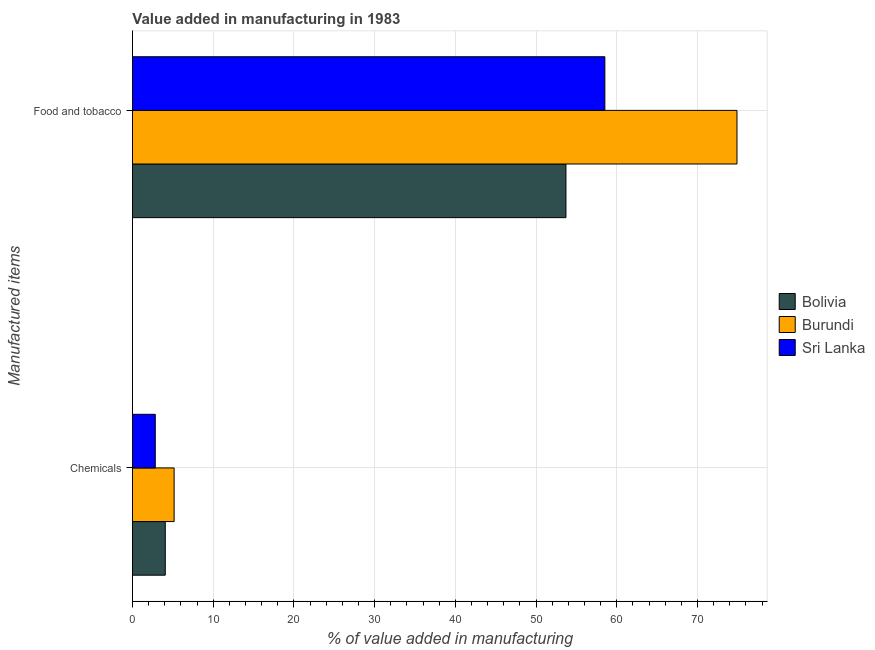Are the number of bars on each tick of the Y-axis equal?
Provide a short and direct response. Yes. How many bars are there on the 2nd tick from the bottom?
Offer a very short reply. 3. What is the label of the 1st group of bars from the top?
Make the answer very short. Food and tobacco. What is the value added by manufacturing food and tobacco in Bolivia?
Your answer should be compact. 53.7. Across all countries, what is the maximum value added by manufacturing food and tobacco?
Provide a short and direct response. 74.89. Across all countries, what is the minimum value added by manufacturing food and tobacco?
Offer a very short reply. 53.7. In which country was the value added by  manufacturing chemicals maximum?
Keep it short and to the point. Burundi. In which country was the value added by  manufacturing chemicals minimum?
Offer a terse response. Sri Lanka. What is the total value added by manufacturing food and tobacco in the graph?
Provide a short and direct response. 187.11. What is the difference between the value added by  manufacturing chemicals in Sri Lanka and that in Burundi?
Your answer should be compact. -2.34. What is the difference between the value added by manufacturing food and tobacco in Sri Lanka and the value added by  manufacturing chemicals in Burundi?
Offer a very short reply. 53.35. What is the average value added by manufacturing food and tobacco per country?
Give a very brief answer. 62.37. What is the difference between the value added by  manufacturing chemicals and value added by manufacturing food and tobacco in Sri Lanka?
Your answer should be compact. -55.69. In how many countries, is the value added by  manufacturing chemicals greater than 14 %?
Offer a very short reply. 0. What is the ratio of the value added by manufacturing food and tobacco in Sri Lanka to that in Burundi?
Your answer should be very brief. 0.78. Is the value added by  manufacturing chemicals in Burundi less than that in Bolivia?
Keep it short and to the point. No. In how many countries, is the value added by manufacturing food and tobacco greater than the average value added by manufacturing food and tobacco taken over all countries?
Offer a very short reply. 1. What does the 2nd bar from the top in Food and tobacco represents?
Provide a short and direct response. Burundi. What does the 3rd bar from the bottom in Food and tobacco represents?
Give a very brief answer. Sri Lanka. Are all the bars in the graph horizontal?
Give a very brief answer. Yes. What is the difference between two consecutive major ticks on the X-axis?
Offer a very short reply. 10. Are the values on the major ticks of X-axis written in scientific E-notation?
Provide a short and direct response. No. Does the graph contain any zero values?
Make the answer very short. No. Where does the legend appear in the graph?
Your answer should be compact. Center right. How many legend labels are there?
Provide a succinct answer. 3. What is the title of the graph?
Your response must be concise. Value added in manufacturing in 1983. Does "Philippines" appear as one of the legend labels in the graph?
Offer a terse response. No. What is the label or title of the X-axis?
Offer a terse response. % of value added in manufacturing. What is the label or title of the Y-axis?
Your answer should be compact. Manufactured items. What is the % of value added in manufacturing in Bolivia in Chemicals?
Keep it short and to the point. 4.07. What is the % of value added in manufacturing of Burundi in Chemicals?
Offer a terse response. 5.17. What is the % of value added in manufacturing of Sri Lanka in Chemicals?
Ensure brevity in your answer.  2.83. What is the % of value added in manufacturing in Bolivia in Food and tobacco?
Provide a succinct answer. 53.7. What is the % of value added in manufacturing in Burundi in Food and tobacco?
Provide a short and direct response. 74.89. What is the % of value added in manufacturing in Sri Lanka in Food and tobacco?
Offer a terse response. 58.52. Across all Manufactured items, what is the maximum % of value added in manufacturing in Bolivia?
Make the answer very short. 53.7. Across all Manufactured items, what is the maximum % of value added in manufacturing of Burundi?
Your answer should be very brief. 74.89. Across all Manufactured items, what is the maximum % of value added in manufacturing in Sri Lanka?
Offer a very short reply. 58.52. Across all Manufactured items, what is the minimum % of value added in manufacturing of Bolivia?
Give a very brief answer. 4.07. Across all Manufactured items, what is the minimum % of value added in manufacturing of Burundi?
Your answer should be compact. 5.17. Across all Manufactured items, what is the minimum % of value added in manufacturing of Sri Lanka?
Make the answer very short. 2.83. What is the total % of value added in manufacturing of Bolivia in the graph?
Offer a terse response. 57.77. What is the total % of value added in manufacturing in Burundi in the graph?
Your answer should be compact. 80.05. What is the total % of value added in manufacturing of Sri Lanka in the graph?
Offer a very short reply. 61.35. What is the difference between the % of value added in manufacturing in Bolivia in Chemicals and that in Food and tobacco?
Your answer should be compact. -49.63. What is the difference between the % of value added in manufacturing in Burundi in Chemicals and that in Food and tobacco?
Keep it short and to the point. -69.72. What is the difference between the % of value added in manufacturing of Sri Lanka in Chemicals and that in Food and tobacco?
Provide a short and direct response. -55.69. What is the difference between the % of value added in manufacturing of Bolivia in Chemicals and the % of value added in manufacturing of Burundi in Food and tobacco?
Keep it short and to the point. -70.82. What is the difference between the % of value added in manufacturing in Bolivia in Chemicals and the % of value added in manufacturing in Sri Lanka in Food and tobacco?
Your answer should be compact. -54.45. What is the difference between the % of value added in manufacturing in Burundi in Chemicals and the % of value added in manufacturing in Sri Lanka in Food and tobacco?
Make the answer very short. -53.35. What is the average % of value added in manufacturing of Bolivia per Manufactured items?
Make the answer very short. 28.88. What is the average % of value added in manufacturing of Burundi per Manufactured items?
Give a very brief answer. 40.03. What is the average % of value added in manufacturing in Sri Lanka per Manufactured items?
Provide a succinct answer. 30.68. What is the difference between the % of value added in manufacturing in Bolivia and % of value added in manufacturing in Burundi in Chemicals?
Your answer should be compact. -1.1. What is the difference between the % of value added in manufacturing in Bolivia and % of value added in manufacturing in Sri Lanka in Chemicals?
Provide a short and direct response. 1.24. What is the difference between the % of value added in manufacturing of Burundi and % of value added in manufacturing of Sri Lanka in Chemicals?
Make the answer very short. 2.34. What is the difference between the % of value added in manufacturing in Bolivia and % of value added in manufacturing in Burundi in Food and tobacco?
Give a very brief answer. -21.19. What is the difference between the % of value added in manufacturing in Bolivia and % of value added in manufacturing in Sri Lanka in Food and tobacco?
Provide a short and direct response. -4.82. What is the difference between the % of value added in manufacturing in Burundi and % of value added in manufacturing in Sri Lanka in Food and tobacco?
Offer a very short reply. 16.37. What is the ratio of the % of value added in manufacturing in Bolivia in Chemicals to that in Food and tobacco?
Give a very brief answer. 0.08. What is the ratio of the % of value added in manufacturing of Burundi in Chemicals to that in Food and tobacco?
Your answer should be very brief. 0.07. What is the ratio of the % of value added in manufacturing of Sri Lanka in Chemicals to that in Food and tobacco?
Your response must be concise. 0.05. What is the difference between the highest and the second highest % of value added in manufacturing in Bolivia?
Give a very brief answer. 49.63. What is the difference between the highest and the second highest % of value added in manufacturing of Burundi?
Your answer should be very brief. 69.72. What is the difference between the highest and the second highest % of value added in manufacturing in Sri Lanka?
Your answer should be very brief. 55.69. What is the difference between the highest and the lowest % of value added in manufacturing in Bolivia?
Keep it short and to the point. 49.63. What is the difference between the highest and the lowest % of value added in manufacturing in Burundi?
Give a very brief answer. 69.72. What is the difference between the highest and the lowest % of value added in manufacturing of Sri Lanka?
Your answer should be very brief. 55.69. 